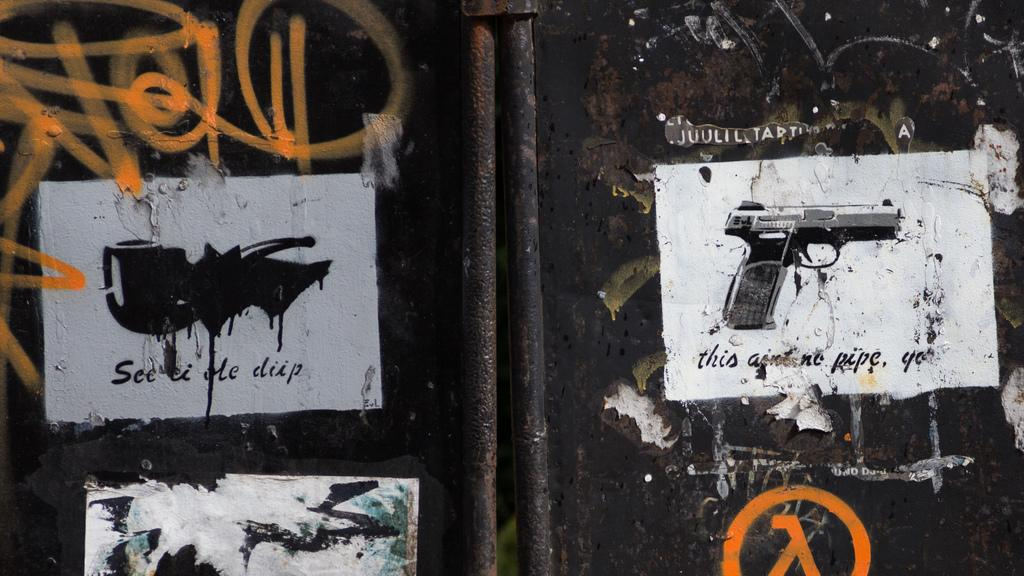What is the color of the objects in the image? The objects in the image are black-colored. What can be seen on the black-colored objects? There are different types of paintings on the black-colored objects. Is there any text present in the image? Yes, there is writing present at a few places in the image. What type of vegetable is being used to create the paintings on the black-colored objects? There is no vegetable present in the image, and vegetables are not used to create the paintings. 